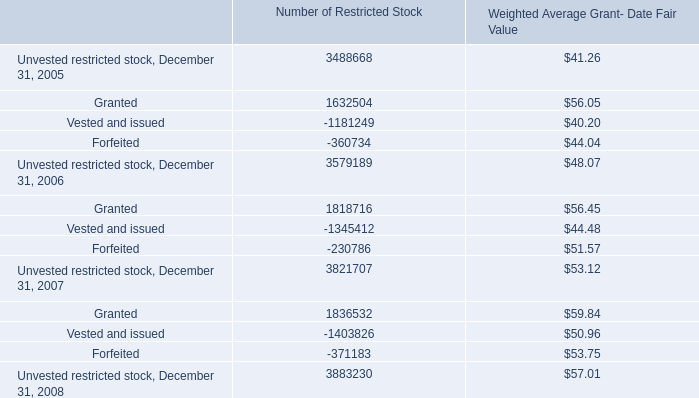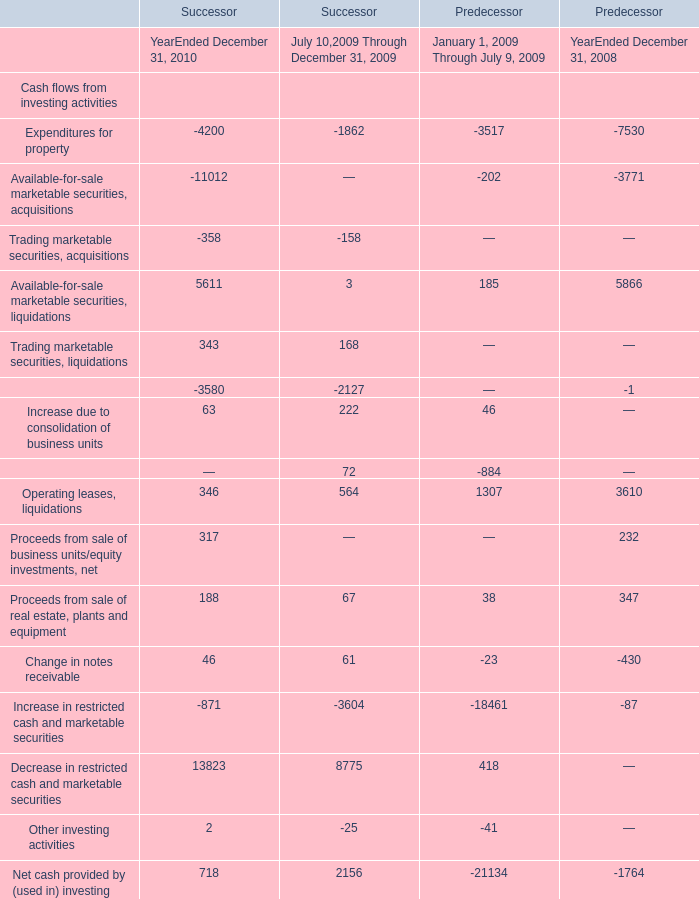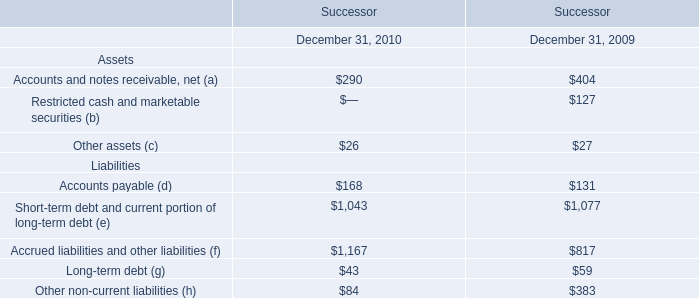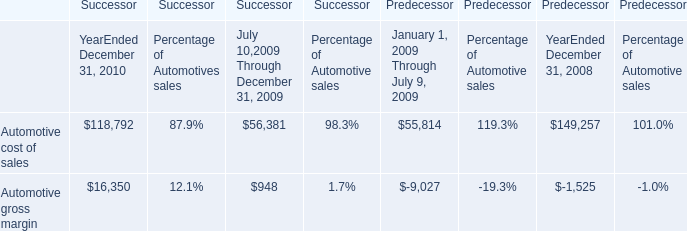Which year is Proceeds from sale of real estate, plants and equipment greater than 100 ? 
Answer: 2010 2008. 